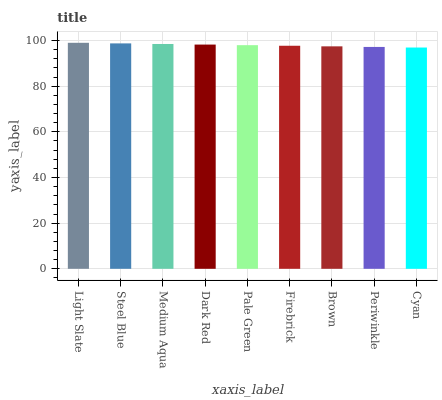Is Cyan the minimum?
Answer yes or no. Yes. Is Light Slate the maximum?
Answer yes or no. Yes. Is Steel Blue the minimum?
Answer yes or no. No. Is Steel Blue the maximum?
Answer yes or no. No. Is Light Slate greater than Steel Blue?
Answer yes or no. Yes. Is Steel Blue less than Light Slate?
Answer yes or no. Yes. Is Steel Blue greater than Light Slate?
Answer yes or no. No. Is Light Slate less than Steel Blue?
Answer yes or no. No. Is Pale Green the high median?
Answer yes or no. Yes. Is Pale Green the low median?
Answer yes or no. Yes. Is Cyan the high median?
Answer yes or no. No. Is Steel Blue the low median?
Answer yes or no. No. 